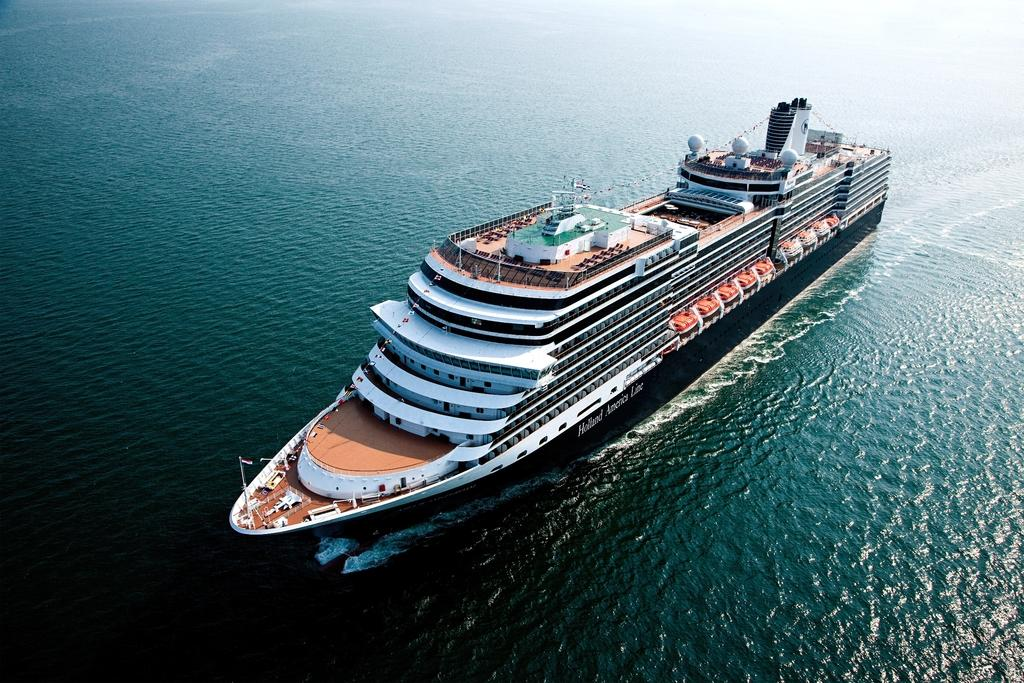What is the main subject of the image? The main subject of the image is a ship. Where is the ship located? The ship is on the water. What can be found on the ship? There are objects on the ship. How does the group of people on the ship react to the loss of their favorite drink? There is no group of people or mention of a favorite drink in the image, so this question cannot be answered. 